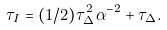<formula> <loc_0><loc_0><loc_500><loc_500>\tau _ { I } = ( 1 / 2 ) \tau _ { \Delta } ^ { 2 } \alpha ^ { - 2 } + \tau _ { \Delta } .</formula> 